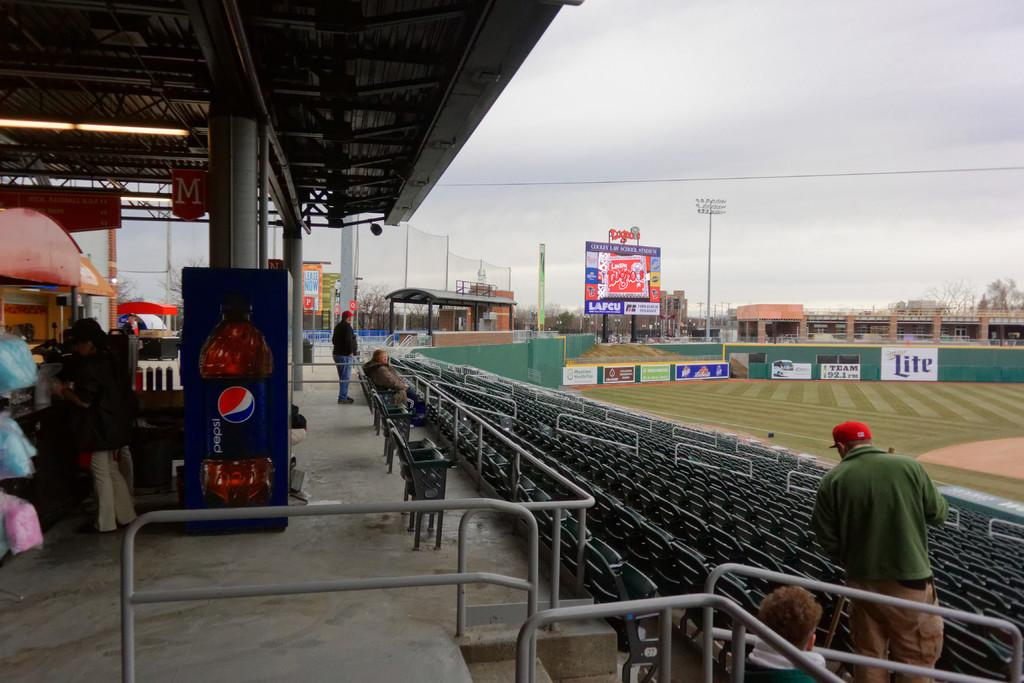<image>
Share a concise interpretation of the image provided. A baseball field with an ad for Miller Lite 